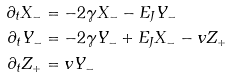Convert formula to latex. <formula><loc_0><loc_0><loc_500><loc_500>\partial _ { t } X _ { - } & = - 2 \gamma X _ { - } - E _ { J } Y _ { - } \\ \partial _ { t } Y _ { - } & = - 2 \gamma Y _ { - } + E _ { J } X _ { - } - v Z _ { + } \\ \partial _ { t } Z _ { + } & = v Y _ { - } \\</formula> 